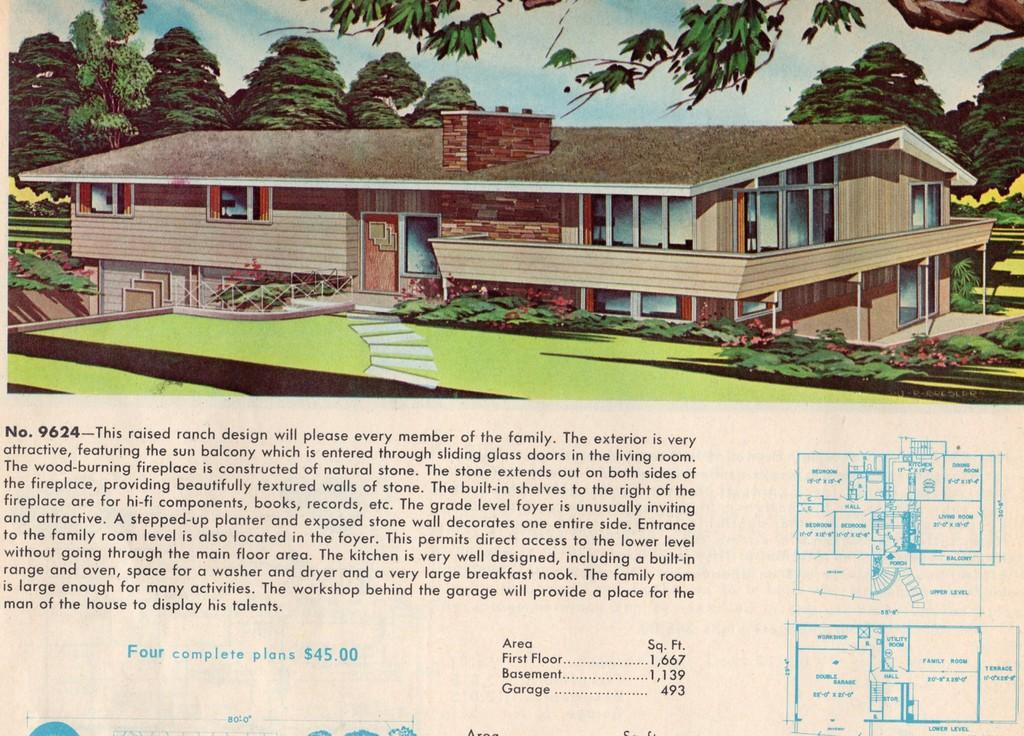What types of images are present on the paper? There is an image of a building and an image of a tree on the paper. What else can be found on the paper besides the images? There is text on the paper. How many snakes are slithering around the tree in the image? There are no snakes present in the image; it features an image of a tree and a building, along with text. What type of cherry is being discussed in the text on the paper? There is no mention of cherries in the text on the paper. 